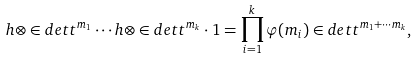<formula> <loc_0><loc_0><loc_500><loc_500>\sl h \otimes \in d e t t ^ { m _ { 1 } } \cdots \sl h \otimes \in d e t t ^ { m _ { k } } \cdot 1 = \prod _ { i = 1 } ^ { k } \varphi ( m _ { i } ) \in d e t t ^ { m _ { 1 } + \cdots m _ { k } } ,</formula> 